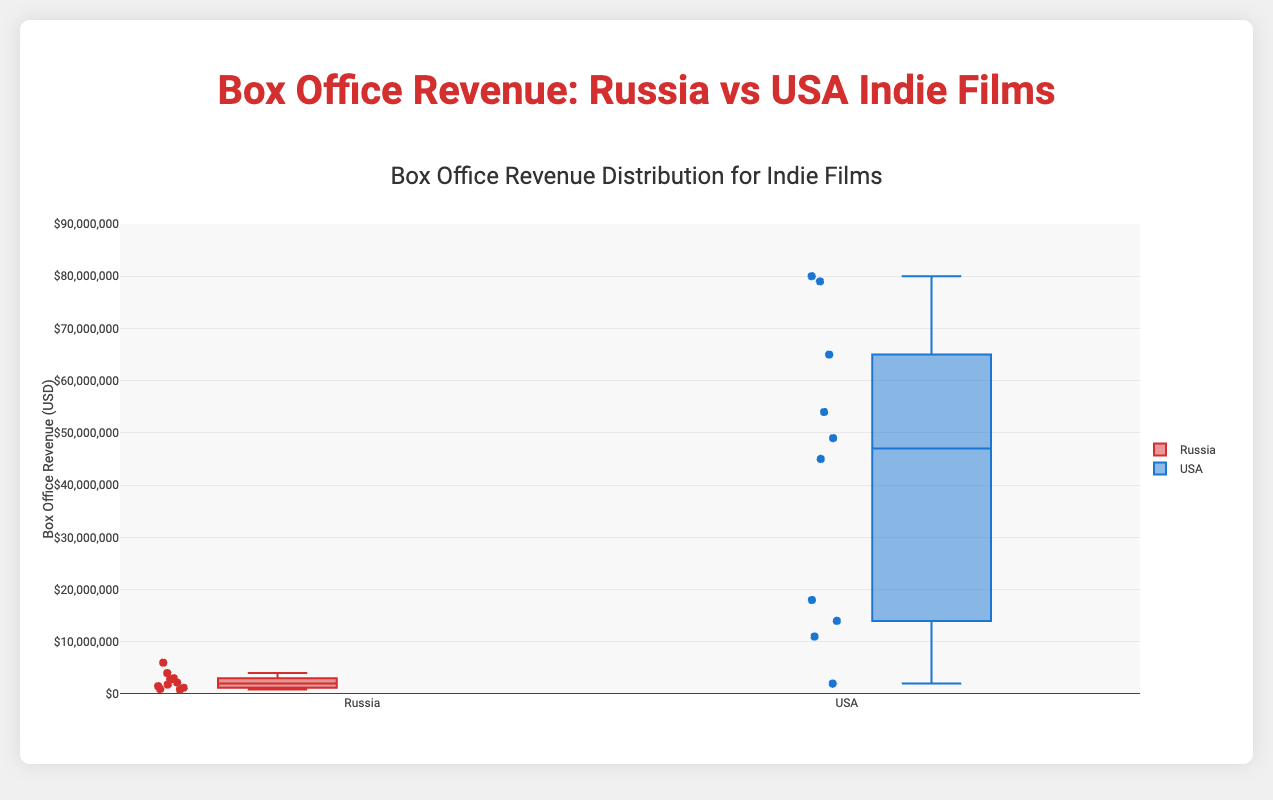What is the title of the figure? The title is located at the top center of the figure, displaying the purpose of the plot, which is to compare box office revenues.
Answer: Box Office Revenue Distribution for Indie Films What is the range of the y-axis? The y-axis range is specified on the left side, highlighting the upper and lower limits of the box office revenues visualized in the plot.
Answer: 0 to 90,000,000 Which country has higher median box office revenue for indie films? The country with the higher median box office revenue will have the middle line of its box plot higher on the y-axis compared to the other country.
Answer: USA How many data points are there for indie films from the USA? Each dot in the box plot represents a data point. Counting these dots under the USA section provides the number.
Answer: 10 What is the median box office revenue for Russian indie films? The median value is represented by the line inside the box plot, which can be read by locating the y-axis value intersecting this line.
Answer: 2,250,000 USD Which country has more variability in box office revenues for indie films? Variability is indicated by the length of the box plot from the lower to upper quartile. The country with the longer box plot band is more variable.
Answer: USA What is the approximate interquartile range (IQR) for Russian indie films box office revenues? The interquartile range (IQR) is calculated by subtracting the lower quartile value from the upper quartile value. Identify these values from the lower and upper bounds of the box.
Answer: ~3,000,000 USD What is the highest box office revenue for a USA indie film, according to the figure? The maximum value can be identified from the top whisker or the highest point in the USA box plot.
Answer: 80,000,000 USD Which USA indie film is an outlier based on the box plot? Outliers are represented by dots outside the whiskers of the box plot. Identify the title of the film at these points.
Answer: A Ghost Story Is there an outlier for Russian indie films? Look for any dots outside the whiskers of the Russian box plot.
Answer: No 